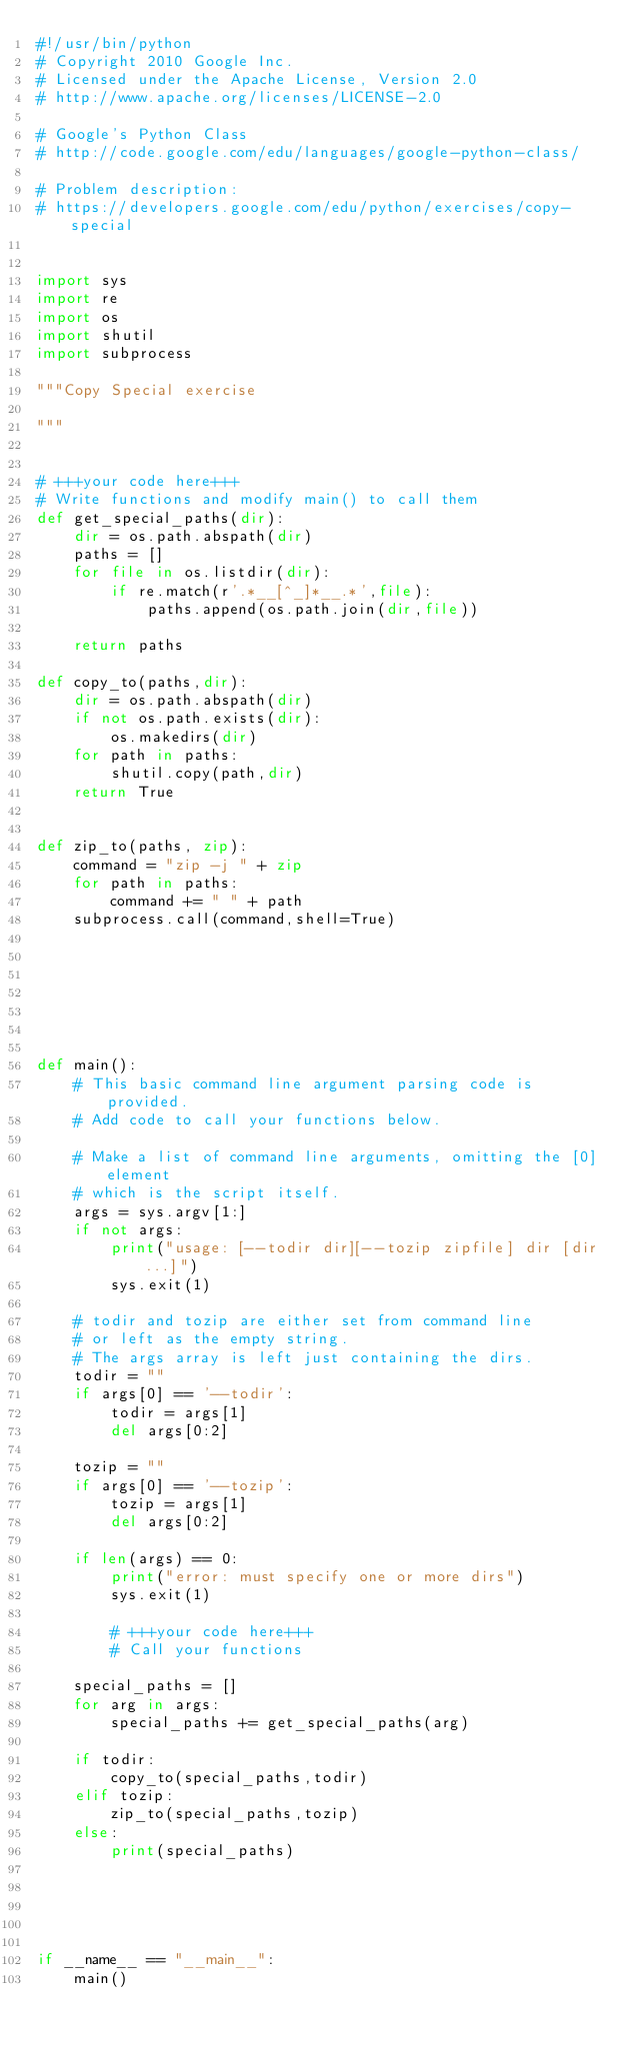<code> <loc_0><loc_0><loc_500><loc_500><_Python_>#!/usr/bin/python
# Copyright 2010 Google Inc.
# Licensed under the Apache License, Version 2.0
# http://www.apache.org/licenses/LICENSE-2.0

# Google's Python Class
# http://code.google.com/edu/languages/google-python-class/

# Problem description:
# https://developers.google.com/edu/python/exercises/copy-special


import sys
import re
import os
import shutil
import subprocess

"""Copy Special exercise

"""


# +++your code here+++
# Write functions and modify main() to call them
def get_special_paths(dir):
    dir = os.path.abspath(dir)
    paths = []
    for file in os.listdir(dir):
        if re.match(r'.*__[^_]*__.*',file):
            paths.append(os.path.join(dir,file))

    return paths

def copy_to(paths,dir):
    dir = os.path.abspath(dir)
    if not os.path.exists(dir):
        os.makedirs(dir)
    for path in paths:
        shutil.copy(path,dir)
    return True


def zip_to(paths, zip):
    command = "zip -j " + zip
    for path in paths:
        command += " " + path
    subprocess.call(command,shell=True)







def main():
    # This basic command line argument parsing code is provided.
    # Add code to call your functions below.

    # Make a list of command line arguments, omitting the [0] element
    # which is the script itself.
    args = sys.argv[1:]
    if not args:
        print("usage: [--todir dir][--tozip zipfile] dir [dir ...]")
        sys.exit(1)

    # todir and tozip are either set from command line
    # or left as the empty string.
    # The args array is left just containing the dirs.
    todir = ""
    if args[0] == '--todir':
        todir = args[1]
        del args[0:2]

    tozip = ""
    if args[0] == '--tozip':
        tozip = args[1]
        del args[0:2]

    if len(args) == 0:
        print("error: must specify one or more dirs")
        sys.exit(1)

        # +++your code here+++
        # Call your functions

    special_paths = []
    for arg in args:
        special_paths += get_special_paths(arg)

    if todir:
        copy_to(special_paths,todir)
    elif tozip:
        zip_to(special_paths,tozip)
    else:
        print(special_paths)





if __name__ == "__main__":
    main()
</code> 